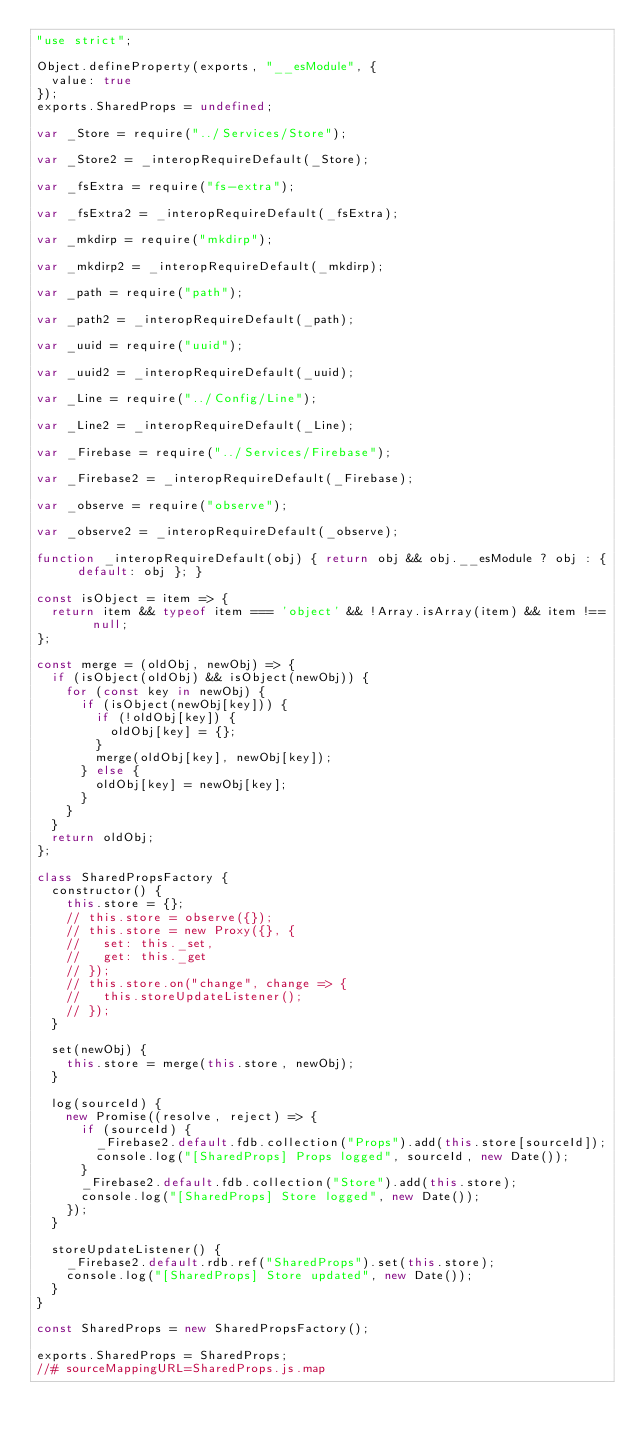Convert code to text. <code><loc_0><loc_0><loc_500><loc_500><_JavaScript_>"use strict";

Object.defineProperty(exports, "__esModule", {
  value: true
});
exports.SharedProps = undefined;

var _Store = require("../Services/Store");

var _Store2 = _interopRequireDefault(_Store);

var _fsExtra = require("fs-extra");

var _fsExtra2 = _interopRequireDefault(_fsExtra);

var _mkdirp = require("mkdirp");

var _mkdirp2 = _interopRequireDefault(_mkdirp);

var _path = require("path");

var _path2 = _interopRequireDefault(_path);

var _uuid = require("uuid");

var _uuid2 = _interopRequireDefault(_uuid);

var _Line = require("../Config/Line");

var _Line2 = _interopRequireDefault(_Line);

var _Firebase = require("../Services/Firebase");

var _Firebase2 = _interopRequireDefault(_Firebase);

var _observe = require("observe");

var _observe2 = _interopRequireDefault(_observe);

function _interopRequireDefault(obj) { return obj && obj.__esModule ? obj : { default: obj }; }

const isObject = item => {
  return item && typeof item === 'object' && !Array.isArray(item) && item !== null;
};

const merge = (oldObj, newObj) => {
  if (isObject(oldObj) && isObject(newObj)) {
    for (const key in newObj) {
      if (isObject(newObj[key])) {
        if (!oldObj[key]) {
          oldObj[key] = {};
        }
        merge(oldObj[key], newObj[key]);
      } else {
        oldObj[key] = newObj[key];
      }
    }
  }
  return oldObj;
};

class SharedPropsFactory {
  constructor() {
    this.store = {};
    // this.store = observe({});
    // this.store = new Proxy({}, {
    //   set: this._set,
    //   get: this._get
    // });
    // this.store.on("change", change => {
    //   this.storeUpdateListener();
    // });
  }

  set(newObj) {
    this.store = merge(this.store, newObj);
  }

  log(sourceId) {
    new Promise((resolve, reject) => {
      if (sourceId) {
        _Firebase2.default.fdb.collection("Props").add(this.store[sourceId]);
        console.log("[SharedProps] Props logged", sourceId, new Date());
      }
      _Firebase2.default.fdb.collection("Store").add(this.store);
      console.log("[SharedProps] Store logged", new Date());
    });
  }

  storeUpdateListener() {
    _Firebase2.default.rdb.ref("SharedProps").set(this.store);
    console.log("[SharedProps] Store updated", new Date());
  }
}

const SharedProps = new SharedPropsFactory();

exports.SharedProps = SharedProps;
//# sourceMappingURL=SharedProps.js.map</code> 